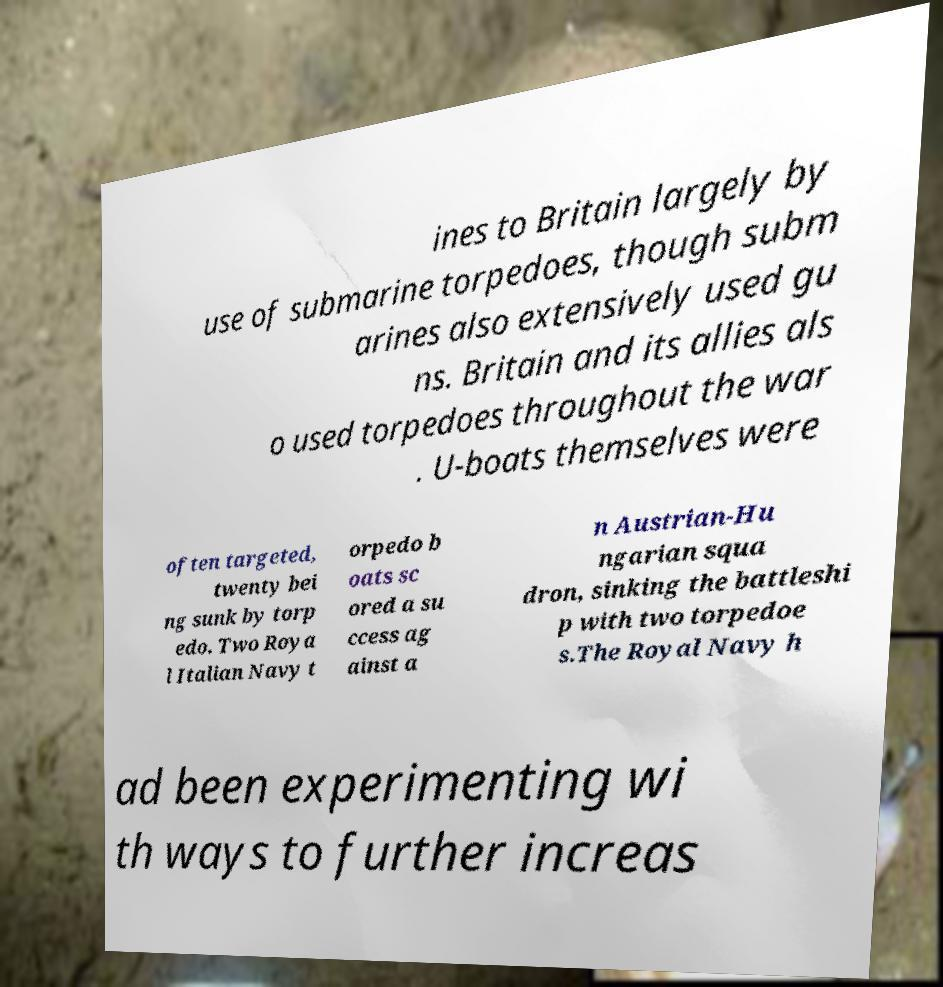For documentation purposes, I need the text within this image transcribed. Could you provide that? ines to Britain largely by use of submarine torpedoes, though subm arines also extensively used gu ns. Britain and its allies als o used torpedoes throughout the war . U-boats themselves were often targeted, twenty bei ng sunk by torp edo. Two Roya l Italian Navy t orpedo b oats sc ored a su ccess ag ainst a n Austrian-Hu ngarian squa dron, sinking the battleshi p with two torpedoe s.The Royal Navy h ad been experimenting wi th ways to further increas 